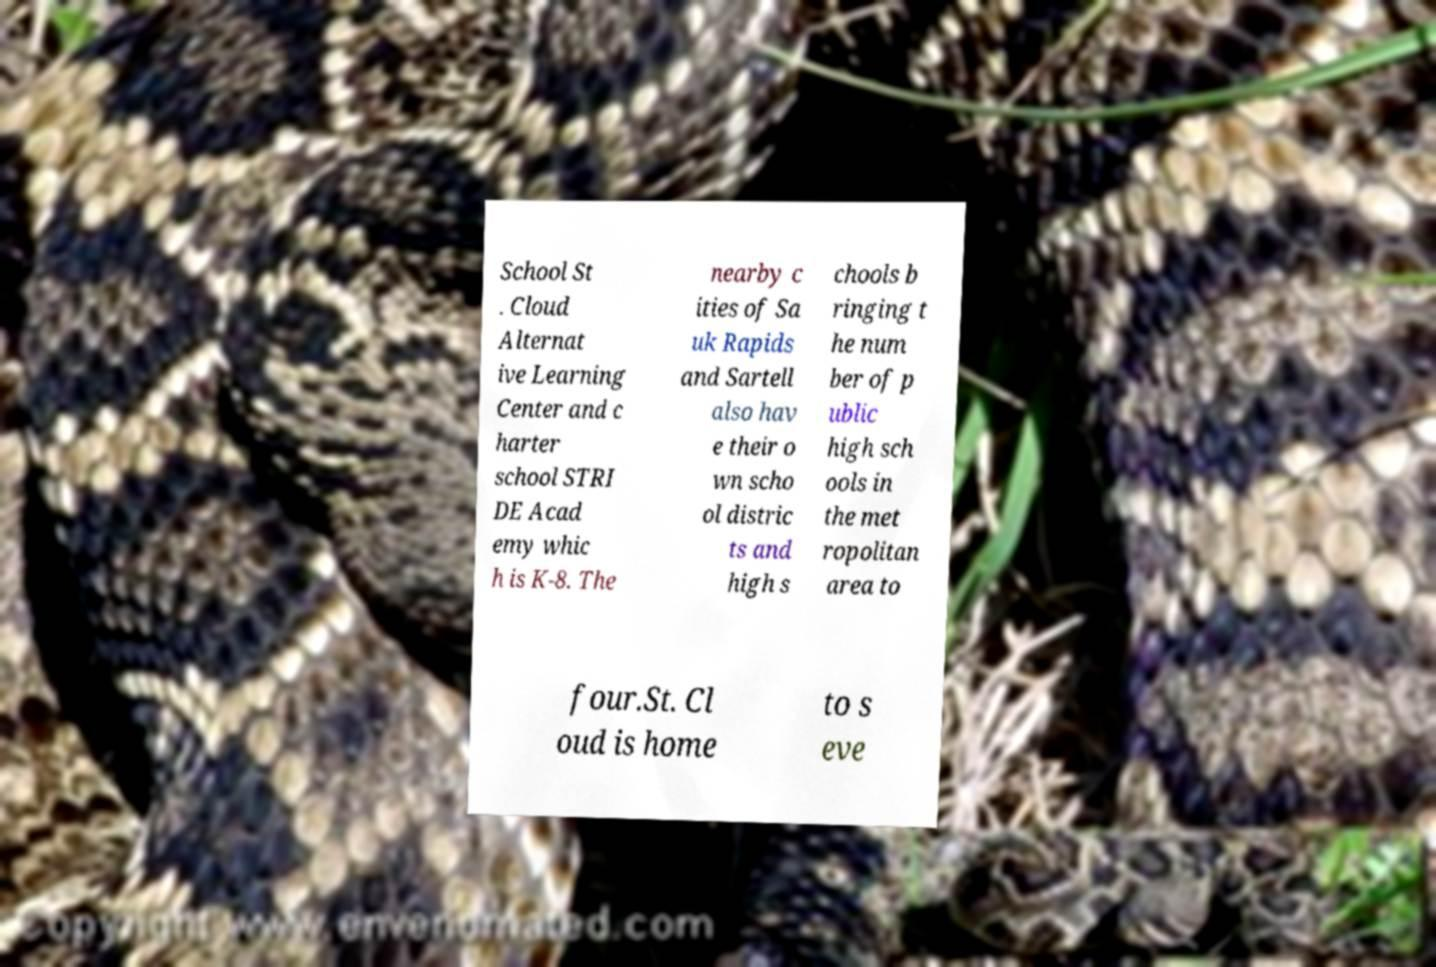There's text embedded in this image that I need extracted. Can you transcribe it verbatim? School St . Cloud Alternat ive Learning Center and c harter school STRI DE Acad emy whic h is K-8. The nearby c ities of Sa uk Rapids and Sartell also hav e their o wn scho ol distric ts and high s chools b ringing t he num ber of p ublic high sch ools in the met ropolitan area to four.St. Cl oud is home to s eve 